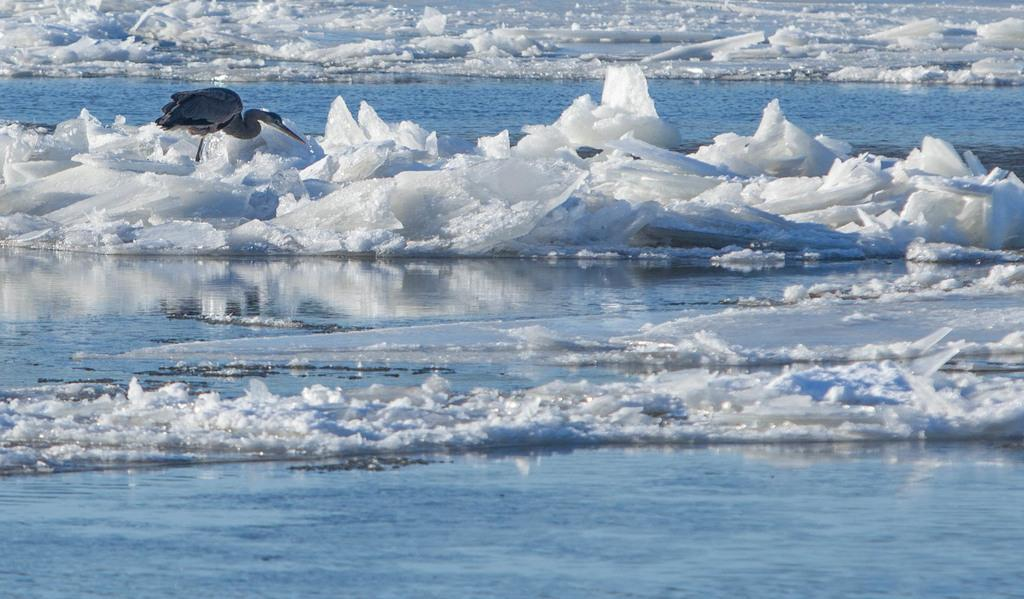What type of machine is in the image? There is a crane in the image. What is present at the bottom of the image? There is ice at the bottom of the image. What else can be seen in the image besides the crane? There is water in the image. What type of stitch is used to hold the ice together in the image? There is no stitching present in the image, as the ice is not held together by any stitching. 